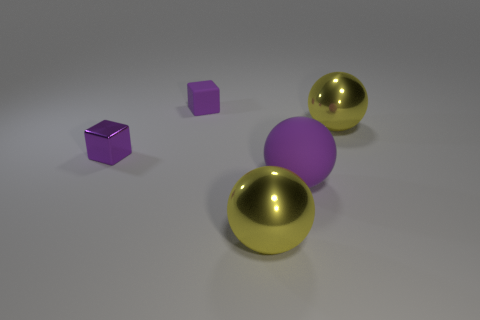There is a small purple metal cube to the left of the big purple matte ball; is there a shiny sphere that is behind it? Yes, indeed there is a shiny sphere located behind the large matte purple ball. To be more precise, there are actually two shiny gold spheres positioned in alignment, with one slightly further away from the viewer than the other and both creating subtle reflections on the surface beneath them. 